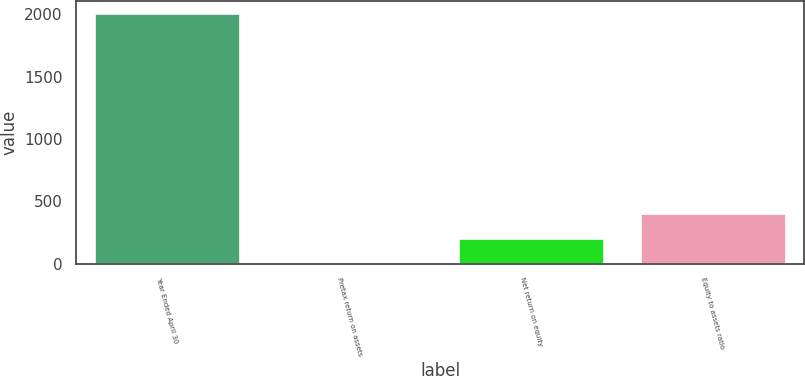Convert chart. <chart><loc_0><loc_0><loc_500><loc_500><bar_chart><fcel>Year Ended April 30<fcel>Pretax return on assets<fcel>Net return on equity<fcel>Equity to assets ratio<nl><fcel>2010<fcel>2.12<fcel>202.91<fcel>403.7<nl></chart> 